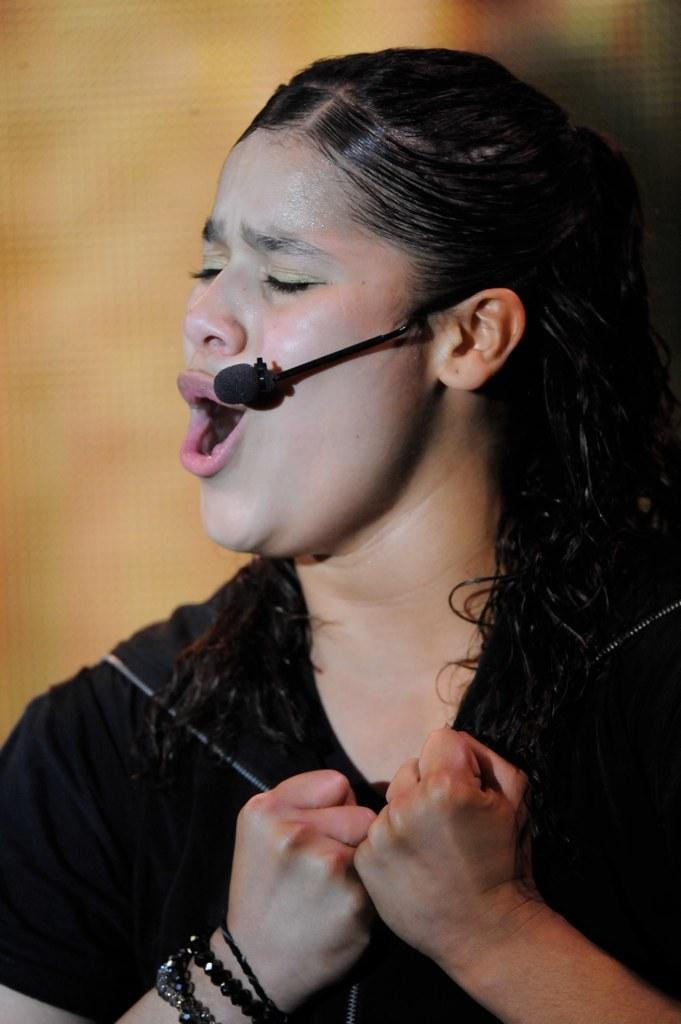Who is the main subject in the image? There is a woman in the image. What is the woman wearing? The woman is wearing clothes and a bracelet. What object is present in the image that is typically used for amplifying sound? There is a microphone in the image. What can be observed about the background of the image? The background of the image is blurred. What activity might the woman be engaged in, based on the presence of the microphone? It appears that the woman is singing. What type of flesh can be seen on the woman's face in the image? There is no flesh visible on the woman's face in the image; it is not possible to determine the texture or appearance of her skin. Who is the woman's partner in the image? There is no partner present in the image; it only features the woman and the microphone. 